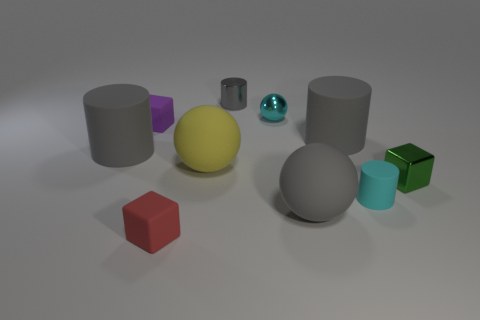Can you tell me the shapes and colors of the objects presented? Certainly, the image displays a variety of geometric shapes in different colors. There are two gray cylinders, a purple cube, a yellow sphere, a silver sphere with a glossy finish, a gray sphere, and two cubes - one red and one green. 